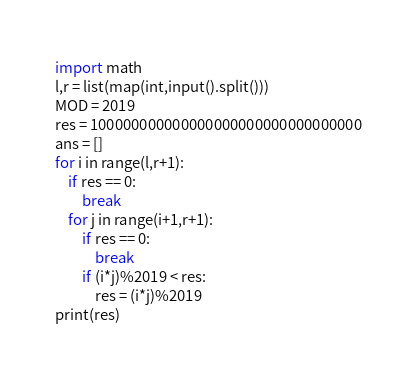<code> <loc_0><loc_0><loc_500><loc_500><_Python_>import math
l,r = list(map(int,input().split()))
MOD = 2019
res = 100000000000000000000000000000000
ans = []
for i in range(l,r+1):
    if res == 0:
        break
    for j in range(i+1,r+1):
        if res == 0:
            break
        if (i*j)%2019 < res:
            res = (i*j)%2019
print(res)
</code> 